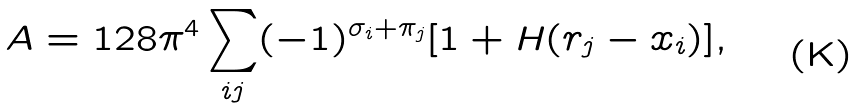Convert formula to latex. <formula><loc_0><loc_0><loc_500><loc_500>A = 1 2 8 \pi ^ { 4 } \sum _ { i j } ( - 1 ) ^ { \sigma _ { i } + \pi _ { j } } [ 1 + H ( r _ { j } - x _ { i } ) ] ,</formula> 